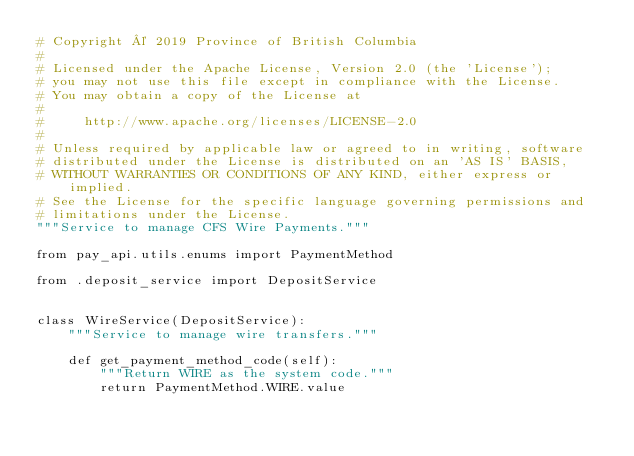<code> <loc_0><loc_0><loc_500><loc_500><_Python_># Copyright © 2019 Province of British Columbia
#
# Licensed under the Apache License, Version 2.0 (the 'License');
# you may not use this file except in compliance with the License.
# You may obtain a copy of the License at
#
#     http://www.apache.org/licenses/LICENSE-2.0
#
# Unless required by applicable law or agreed to in writing, software
# distributed under the License is distributed on an 'AS IS' BASIS,
# WITHOUT WARRANTIES OR CONDITIONS OF ANY KIND, either express or implied.
# See the License for the specific language governing permissions and
# limitations under the License.
"""Service to manage CFS Wire Payments."""

from pay_api.utils.enums import PaymentMethod

from .deposit_service import DepositService


class WireService(DepositService):
    """Service to manage wire transfers."""

    def get_payment_method_code(self):
        """Return WIRE as the system code."""
        return PaymentMethod.WIRE.value
</code> 